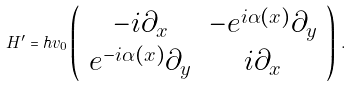Convert formula to latex. <formula><loc_0><loc_0><loc_500><loc_500>H ^ { \prime } = \hbar { v } _ { 0 } \left ( \begin{array} { c c } - i \partial _ { x } & - e ^ { i \alpha ( x ) } \partial _ { y } \\ e ^ { - i \alpha ( x ) } \partial _ { y } & i \partial _ { x } \end{array} \right ) \, .</formula> 